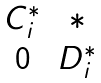<formula> <loc_0><loc_0><loc_500><loc_500>\begin{matrix} C _ { i } ^ { * } & * \\ 0 & D _ { i } ^ { * } \end{matrix}</formula> 